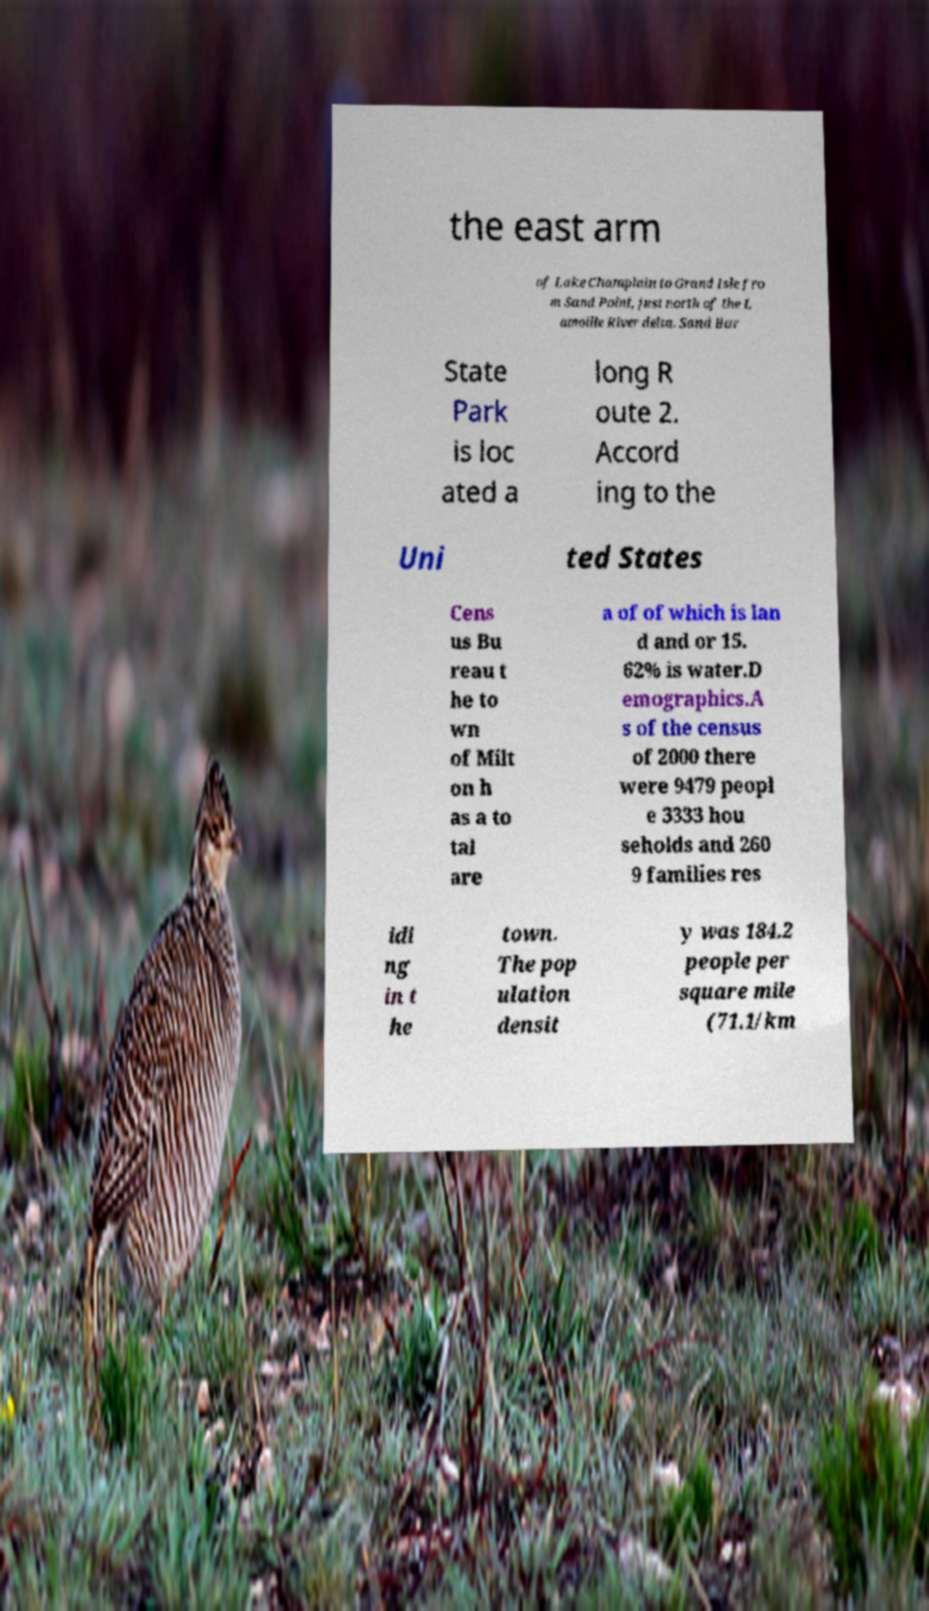There's text embedded in this image that I need extracted. Can you transcribe it verbatim? the east arm of Lake Champlain to Grand Isle fro m Sand Point, just north of the L amoille River delta. Sand Bar State Park is loc ated a long R oute 2. Accord ing to the Uni ted States Cens us Bu reau t he to wn of Milt on h as a to tal are a of of which is lan d and or 15. 62% is water.D emographics.A s of the census of 2000 there were 9479 peopl e 3333 hou seholds and 260 9 families res idi ng in t he town. The pop ulation densit y was 184.2 people per square mile (71.1/km 